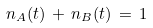<formula> <loc_0><loc_0><loc_500><loc_500>n _ { A } ( t ) \, + \, n _ { B } ( t ) \, = \, 1</formula> 